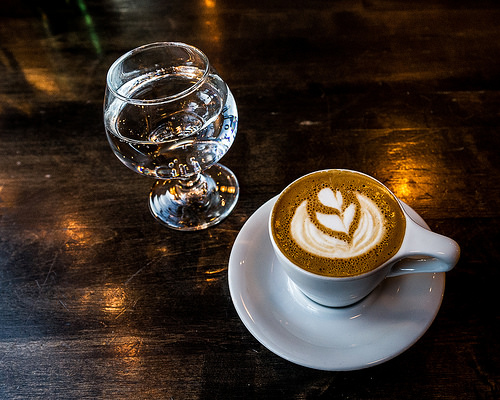<image>
Is the cup in front of the glass? Yes. The cup is positioned in front of the glass, appearing closer to the camera viewpoint. 